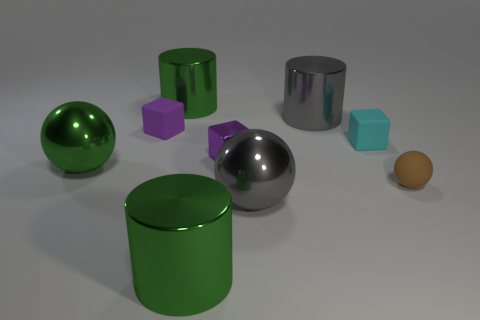What materials do the objects in the image seem to be made of? Based on their appearance, the objects in the image are likely made from various materials. The shiny silver and lighter green cylinder suggest a metallic finish, possibly representing metal, while the matte surfaces of the purple, teal cubes, and the orange sphere suggest they could be made from a solid, non-metallic material like plastic or wood. 